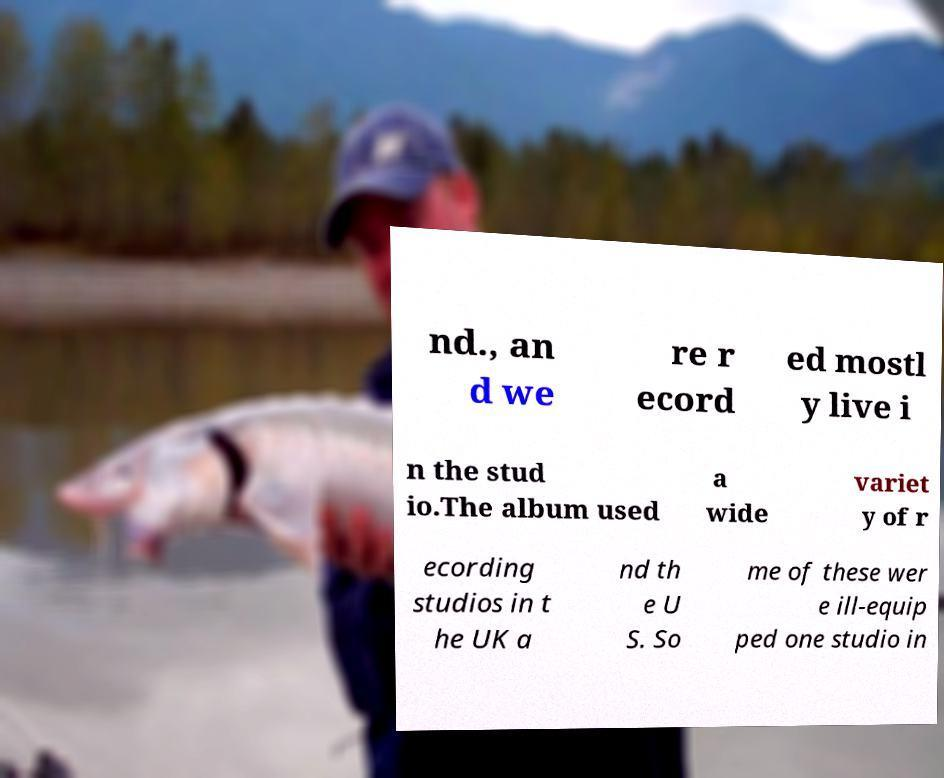Could you assist in decoding the text presented in this image and type it out clearly? nd., an d we re r ecord ed mostl y live i n the stud io.The album used a wide variet y of r ecording studios in t he UK a nd th e U S. So me of these wer e ill-equip ped one studio in 